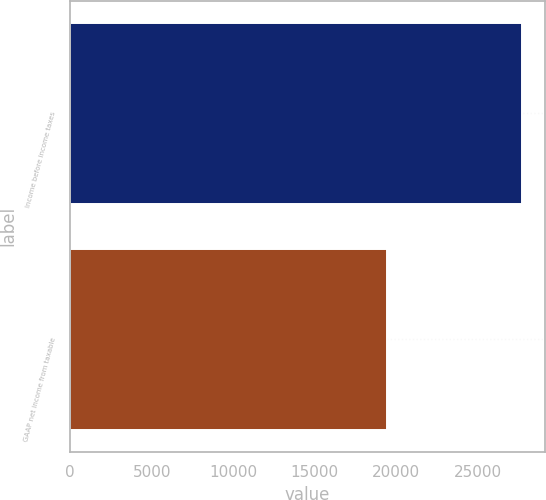<chart> <loc_0><loc_0><loc_500><loc_500><bar_chart><fcel>Income before income taxes<fcel>GAAP net income from taxable<nl><fcel>27716<fcel>19396<nl></chart> 